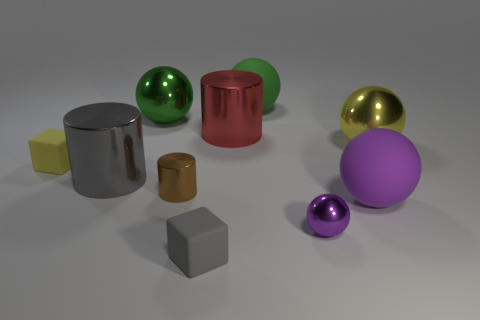Subtract all yellow spheres. How many spheres are left? 4 Subtract all big yellow spheres. How many spheres are left? 4 Subtract 2 balls. How many balls are left? 3 Subtract all blue spheres. Subtract all yellow cylinders. How many spheres are left? 5 Subtract all cylinders. How many objects are left? 7 Subtract 0 red blocks. How many objects are left? 10 Subtract all tiny brown objects. Subtract all purple matte objects. How many objects are left? 8 Add 5 yellow shiny objects. How many yellow shiny objects are left? 6 Add 3 purple metal spheres. How many purple metal spheres exist? 4 